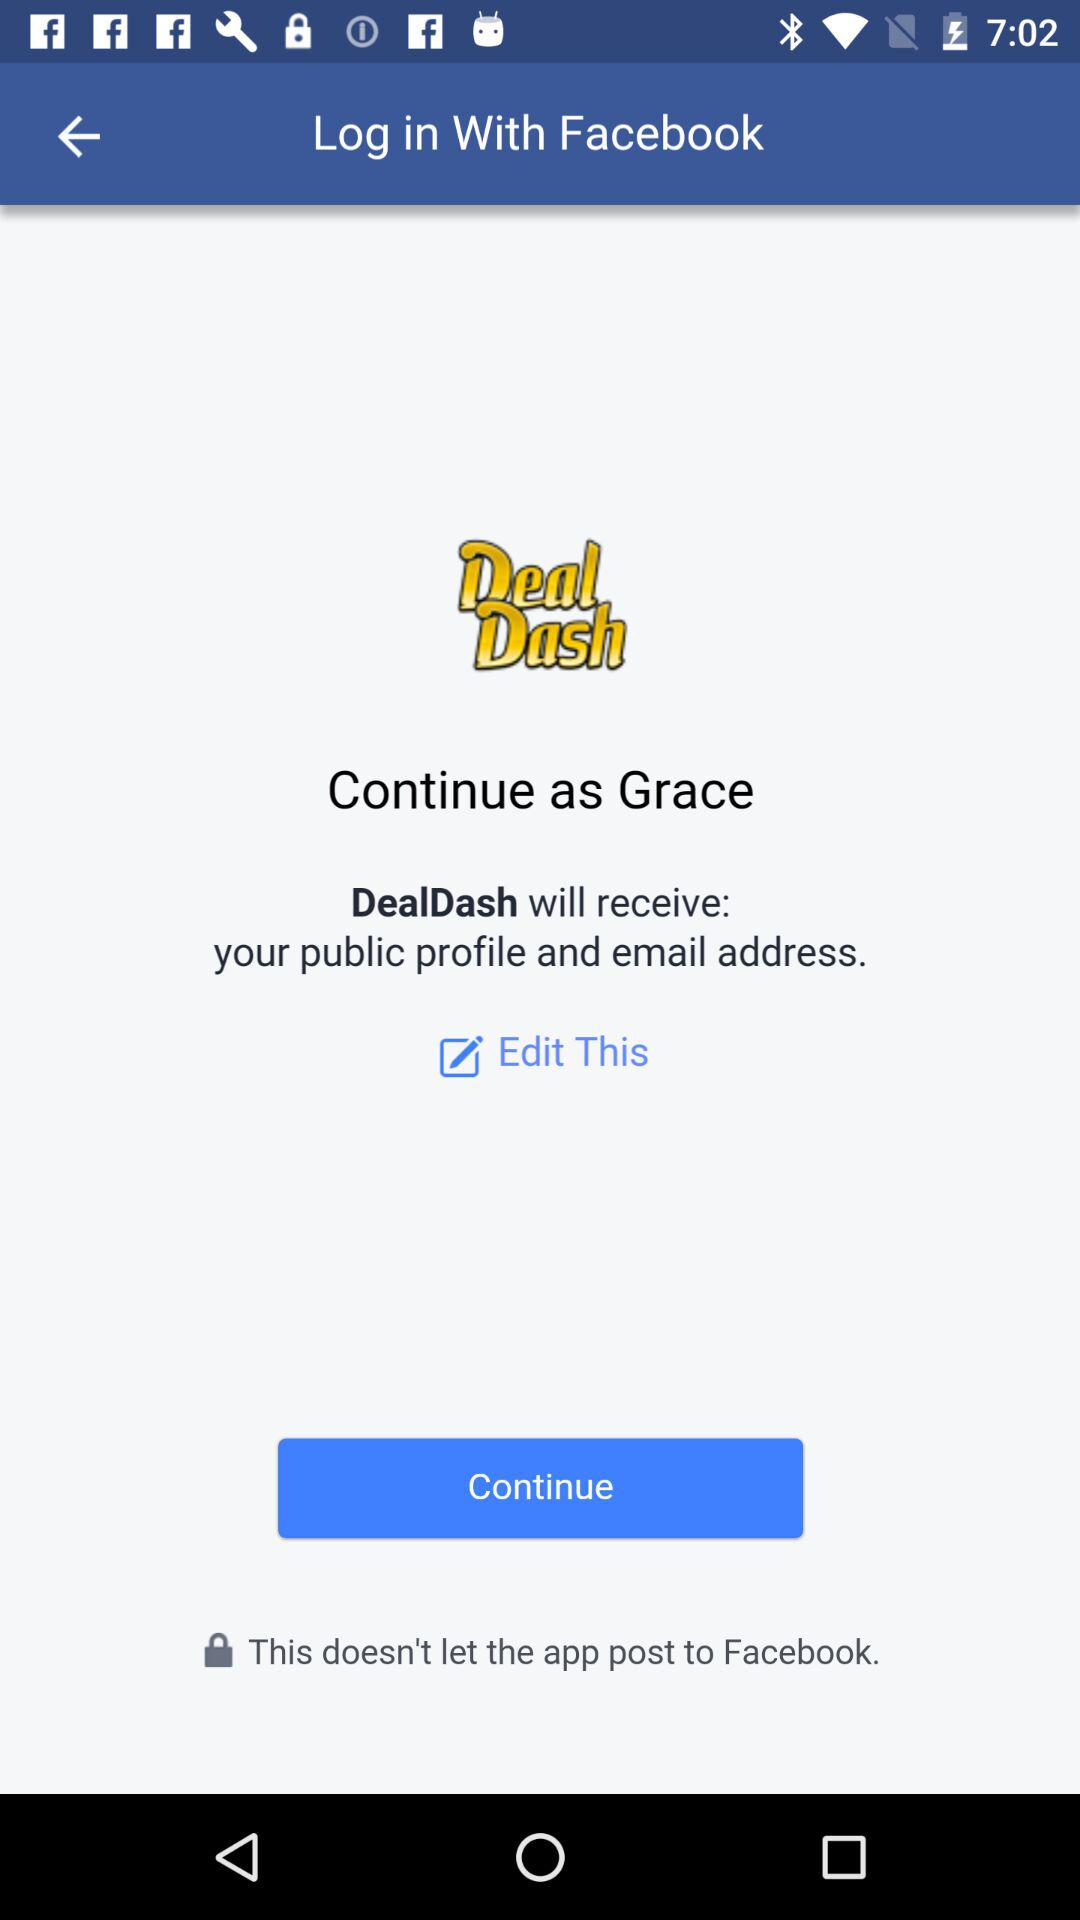What is the name of the application that can be used to log in? The application that can be used to log in is "Facebook". 